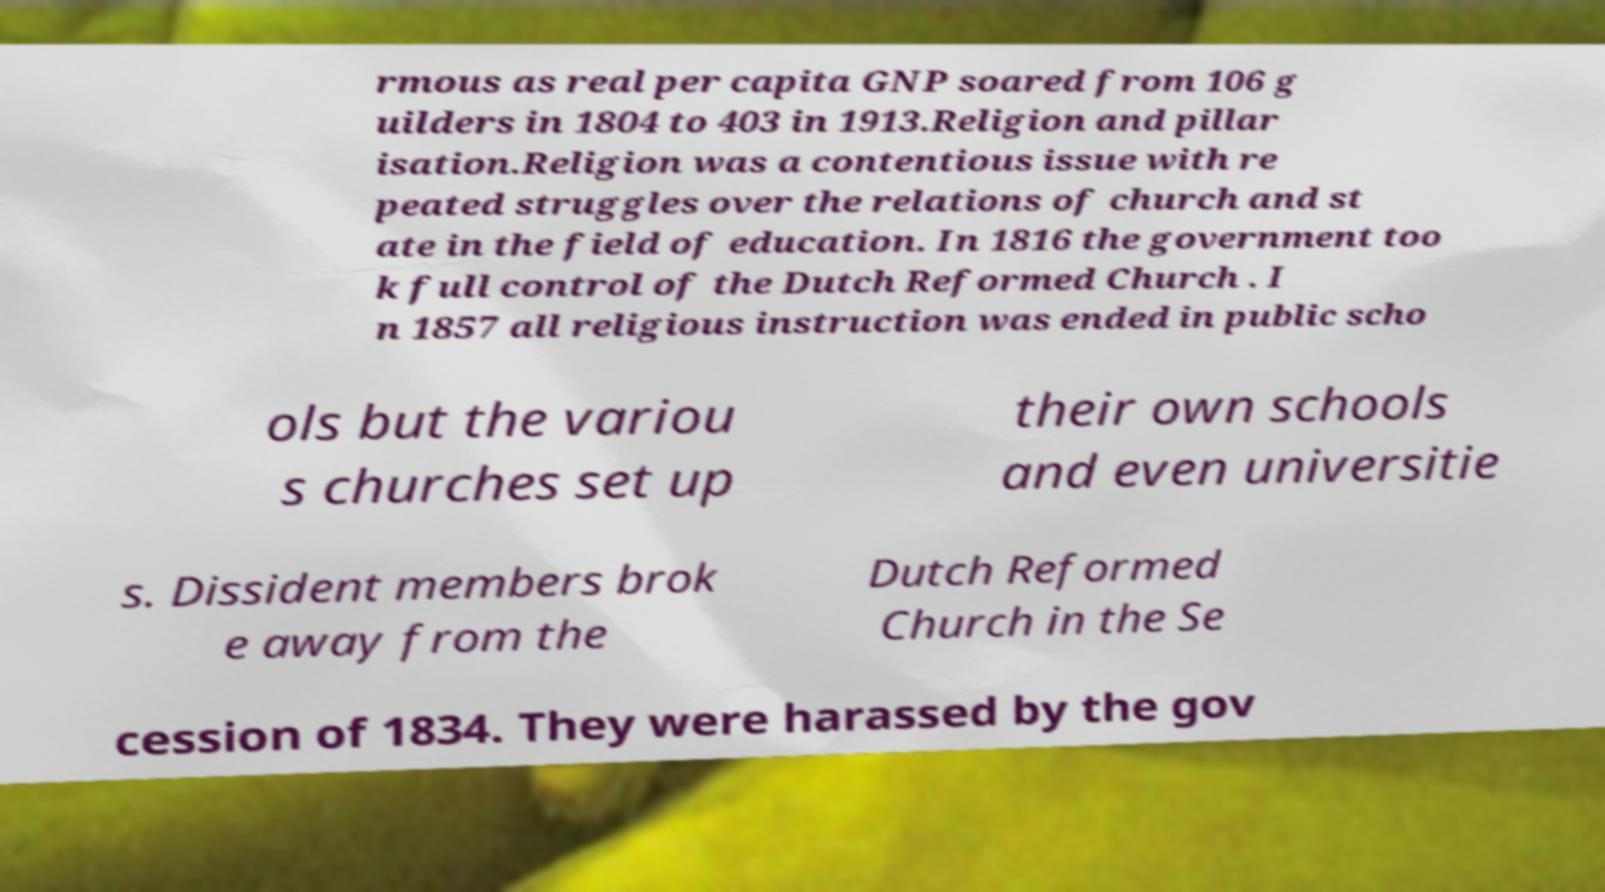Please read and relay the text visible in this image. What does it say? rmous as real per capita GNP soared from 106 g uilders in 1804 to 403 in 1913.Religion and pillar isation.Religion was a contentious issue with re peated struggles over the relations of church and st ate in the field of education. In 1816 the government too k full control of the Dutch Reformed Church . I n 1857 all religious instruction was ended in public scho ols but the variou s churches set up their own schools and even universitie s. Dissident members brok e away from the Dutch Reformed Church in the Se cession of 1834. They were harassed by the gov 